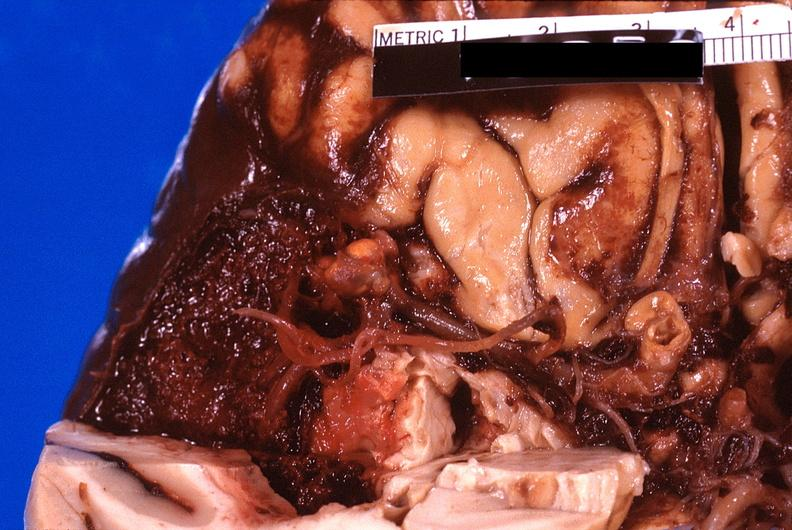s nervous present?
Answer the question using a single word or phrase. Yes 